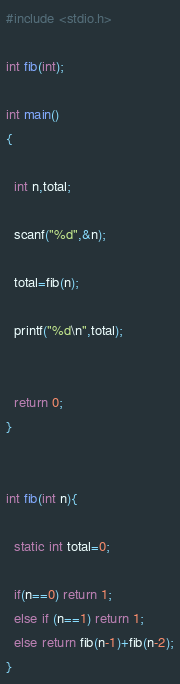<code> <loc_0><loc_0><loc_500><loc_500><_C_>#include <stdio.h>

int fib(int);

int main()
{

  int n,total;

  scanf("%d",&n);

  total=fib(n);

  printf("%d\n",total);

 
  return 0;
}    


int fib(int n){

  static int total=0;

  if(n==0) return 1;
  else if (n==1) return 1;
  else return fib(n-1)+fib(n-2);
}</code> 